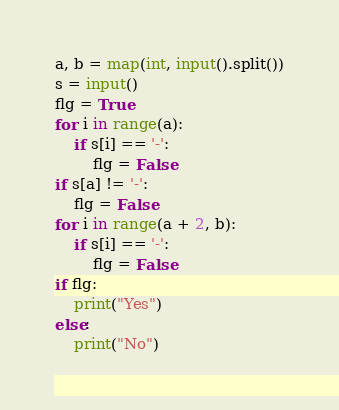Convert code to text. <code><loc_0><loc_0><loc_500><loc_500><_Python_>a, b = map(int, input().split())
s = input()
flg = True
for i in range(a):
    if s[i] == '-':
        flg = False
if s[a] != '-':
    flg = False
for i in range(a + 2, b):
    if s[i] == '-':
        flg = False
if flg:
    print("Yes")
else:
    print("No")</code> 